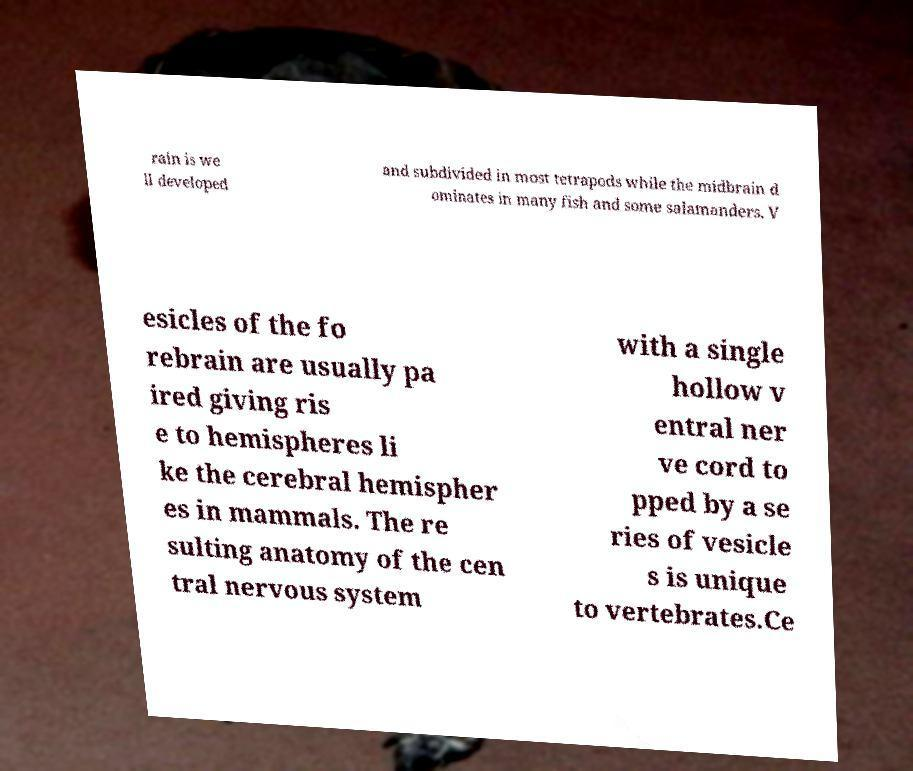Can you read and provide the text displayed in the image?This photo seems to have some interesting text. Can you extract and type it out for me? rain is we ll developed and subdivided in most tetrapods while the midbrain d ominates in many fish and some salamanders. V esicles of the fo rebrain are usually pa ired giving ris e to hemispheres li ke the cerebral hemispher es in mammals. The re sulting anatomy of the cen tral nervous system with a single hollow v entral ner ve cord to pped by a se ries of vesicle s is unique to vertebrates.Ce 